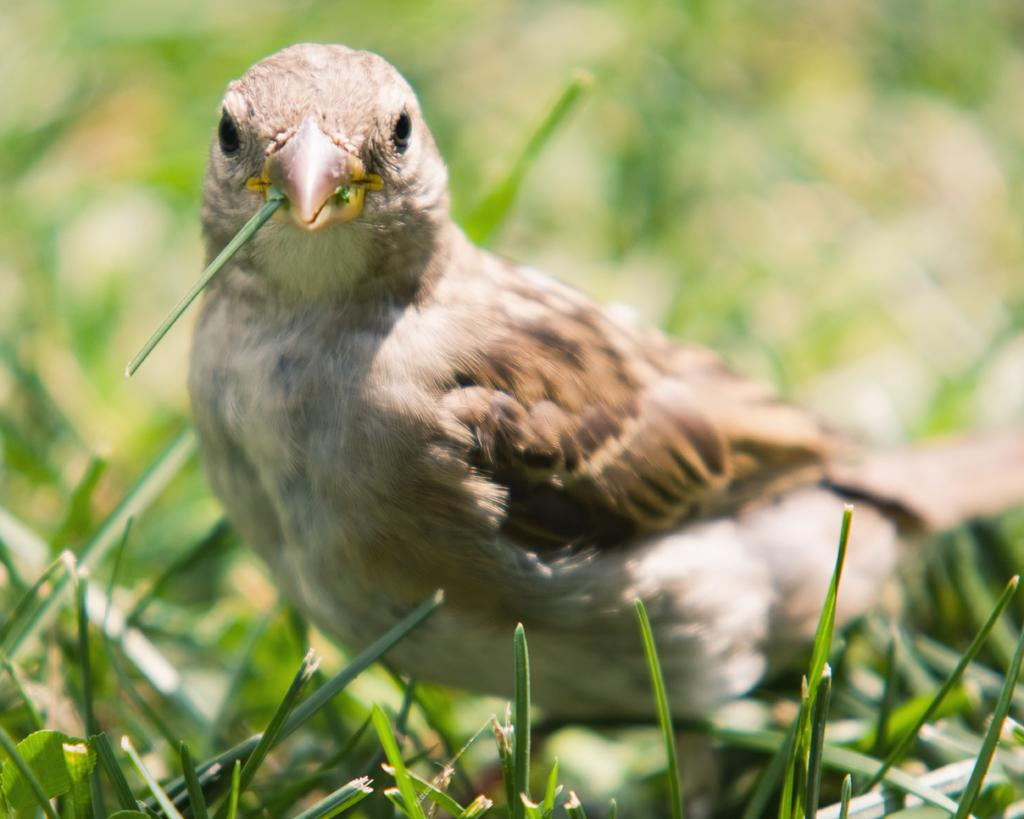What type of animal can be seen in the image? There is a bird in the image. What type of vegetation is present in the image? There is grass in the image. Can you describe the background of the image? The background of the image is blurred. How many muscles does the bird have in the image? It is not possible to determine the number of muscles the bird has in the image, as muscles are not visible. 